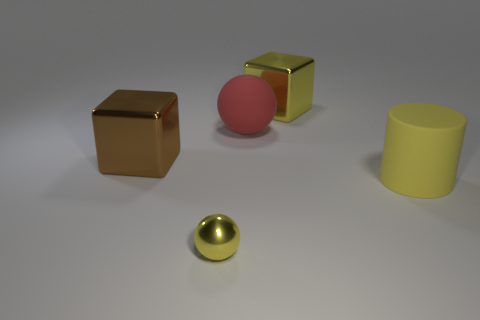There is a cube that is the same color as the cylinder; what size is it?
Your response must be concise. Large. There is a large shiny cube that is on the left side of the yellow cube; what color is it?
Keep it short and to the point. Brown. Is the number of tiny yellow balls that are behind the brown block greater than the number of large red shiny spheres?
Your response must be concise. No. What is the color of the matte cylinder?
Make the answer very short. Yellow. What is the shape of the yellow metallic object that is behind the rubber object that is on the right side of the yellow object that is behind the big yellow rubber object?
Your answer should be compact. Cube. There is a yellow thing that is left of the large yellow cylinder and behind the tiny sphere; what is its material?
Offer a very short reply. Metal. There is a yellow metal thing in front of the big rubber thing that is behind the large yellow rubber cylinder; what is its shape?
Ensure brevity in your answer.  Sphere. Is there any other thing of the same color as the big sphere?
Your answer should be compact. No. Is the size of the brown object the same as the metallic object on the right side of the small shiny thing?
Your response must be concise. Yes. How many small objects are either red matte cylinders or yellow cubes?
Keep it short and to the point. 0. 